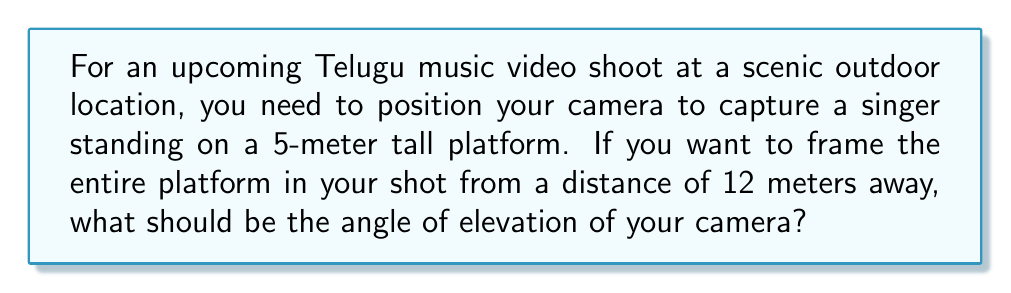Help me with this question. Let's approach this step-by-step using trigonometry:

1) First, let's visualize the scenario:

   [asy]
   import geometry;
   
   size(200);
   
   pair A = (0,0);
   pair B = (12,0);
   pair C = (12,5);
   
   draw(A--B--C--A);
   
   label("Camera", A, SW);
   label("12m", (6,0), S);
   label("5m", (12,2.5), E);
   label("θ", (0.5,0.2), NE);
   
   draw(arc(A,0.7,0,degrees(atan(5/12))),Arrow);
   [/asy]

2) We have a right-angled triangle where:
   - The adjacent side (ground distance) is 12 meters
   - The opposite side (height of the platform) is 5 meters
   - We need to find the angle θ

3) In a right-angled triangle, tan(θ) = opposite / adjacent

4) Therefore, tan(θ) = 5 / 12

5) To find θ, we need to use the inverse tangent (arctan or tan^(-1)):

   θ = tan^(-1)(5/12)

6) Using a calculator or computer:

   θ ≈ 22.62 degrees

This angle represents the elevation needed for the camera to capture the entire 5-meter platform from a distance of 12 meters.
Answer: $\theta = \tan^{-1}(\frac{5}{12}) \approx 22.62°$ 